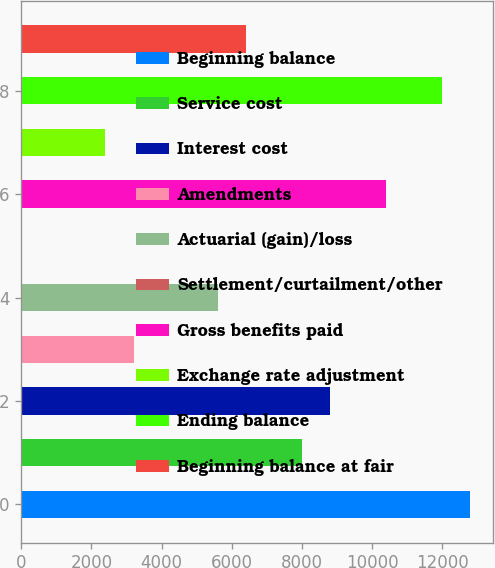Convert chart to OTSL. <chart><loc_0><loc_0><loc_500><loc_500><bar_chart><fcel>Beginning balance<fcel>Service cost<fcel>Interest cost<fcel>Amendments<fcel>Actuarial (gain)/loss<fcel>Settlement/curtailment/other<fcel>Gross benefits paid<fcel>Exchange rate adjustment<fcel>Ending balance<fcel>Beginning balance at fair<nl><fcel>12794.6<fcel>7997<fcel>8796.6<fcel>3199.4<fcel>5598.2<fcel>1<fcel>10395.8<fcel>2399.8<fcel>11995<fcel>6397.8<nl></chart> 